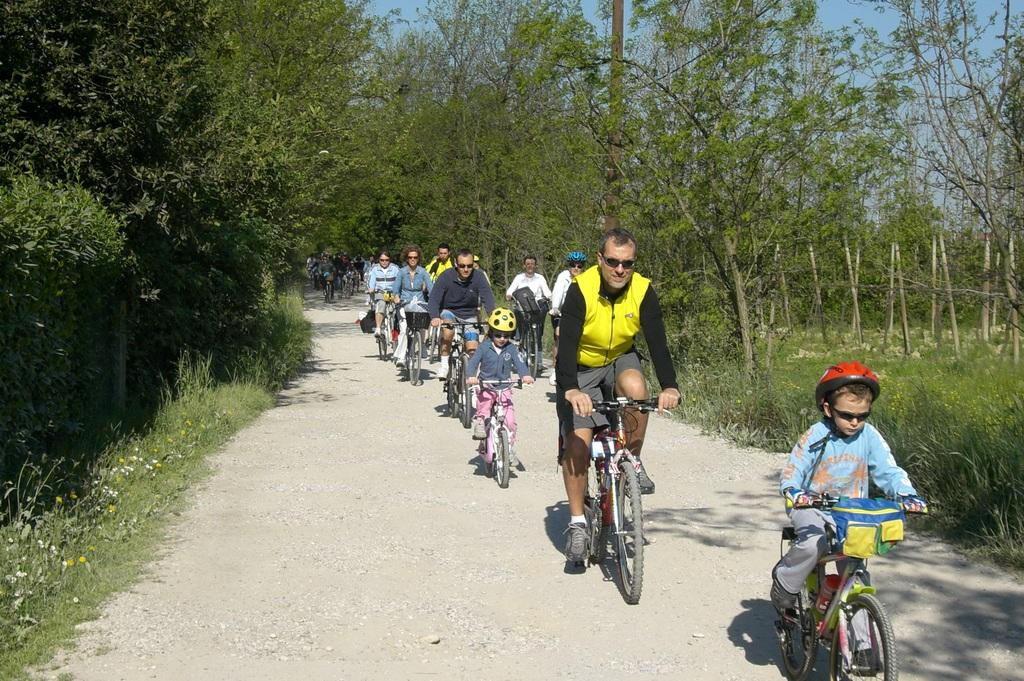What are the people in the image doing? The people in the image are riding bicycles. Where are the people riding their bicycles? The people are riding bicycles on a road. What can be seen beside the road in the image? There are trees beside the road in the image. Can you hear the people coughing while riding their bicycles in the image? There is no sound present in the image, so it is not possible to determine if the people are coughing or not. 